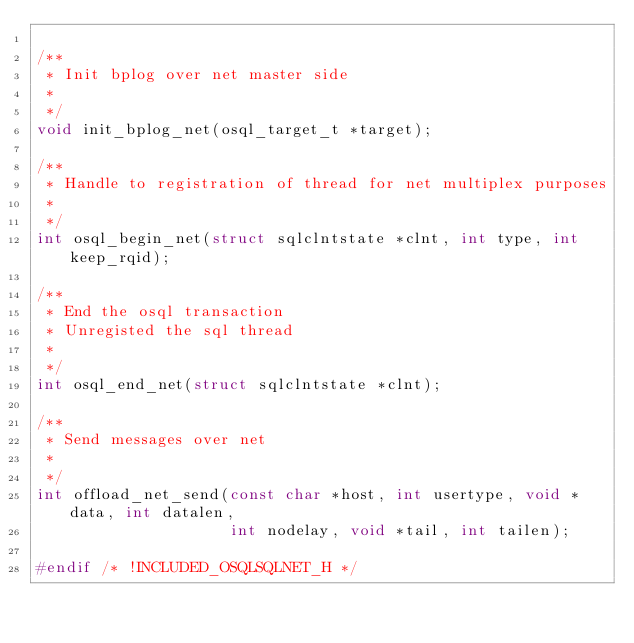<code> <loc_0><loc_0><loc_500><loc_500><_C_>
/**
 * Init bplog over net master side
 *
 */
void init_bplog_net(osql_target_t *target);

/**
 * Handle to registration of thread for net multiplex purposes
 *
 */
int osql_begin_net(struct sqlclntstate *clnt, int type, int keep_rqid);

/**
 * End the osql transaction
 * Unregisted the sql thread
 *
 */
int osql_end_net(struct sqlclntstate *clnt);

/**
 * Send messages over net
 *
 */
int offload_net_send(const char *host, int usertype, void *data, int datalen,
                     int nodelay, void *tail, int tailen);

#endif /* !INCLUDED_OSQLSQLNET_H */
</code> 